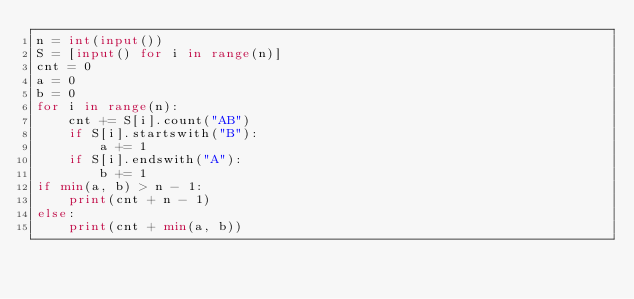Convert code to text. <code><loc_0><loc_0><loc_500><loc_500><_Python_>n = int(input())
S = [input() for i in range(n)]
cnt = 0
a = 0
b = 0
for i in range(n):
    cnt += S[i].count("AB")
    if S[i].startswith("B"):
        a += 1
    if S[i].endswith("A"):
        b += 1
if min(a, b) > n - 1:
    print(cnt + n - 1)
else:
    print(cnt + min(a, b))
</code> 